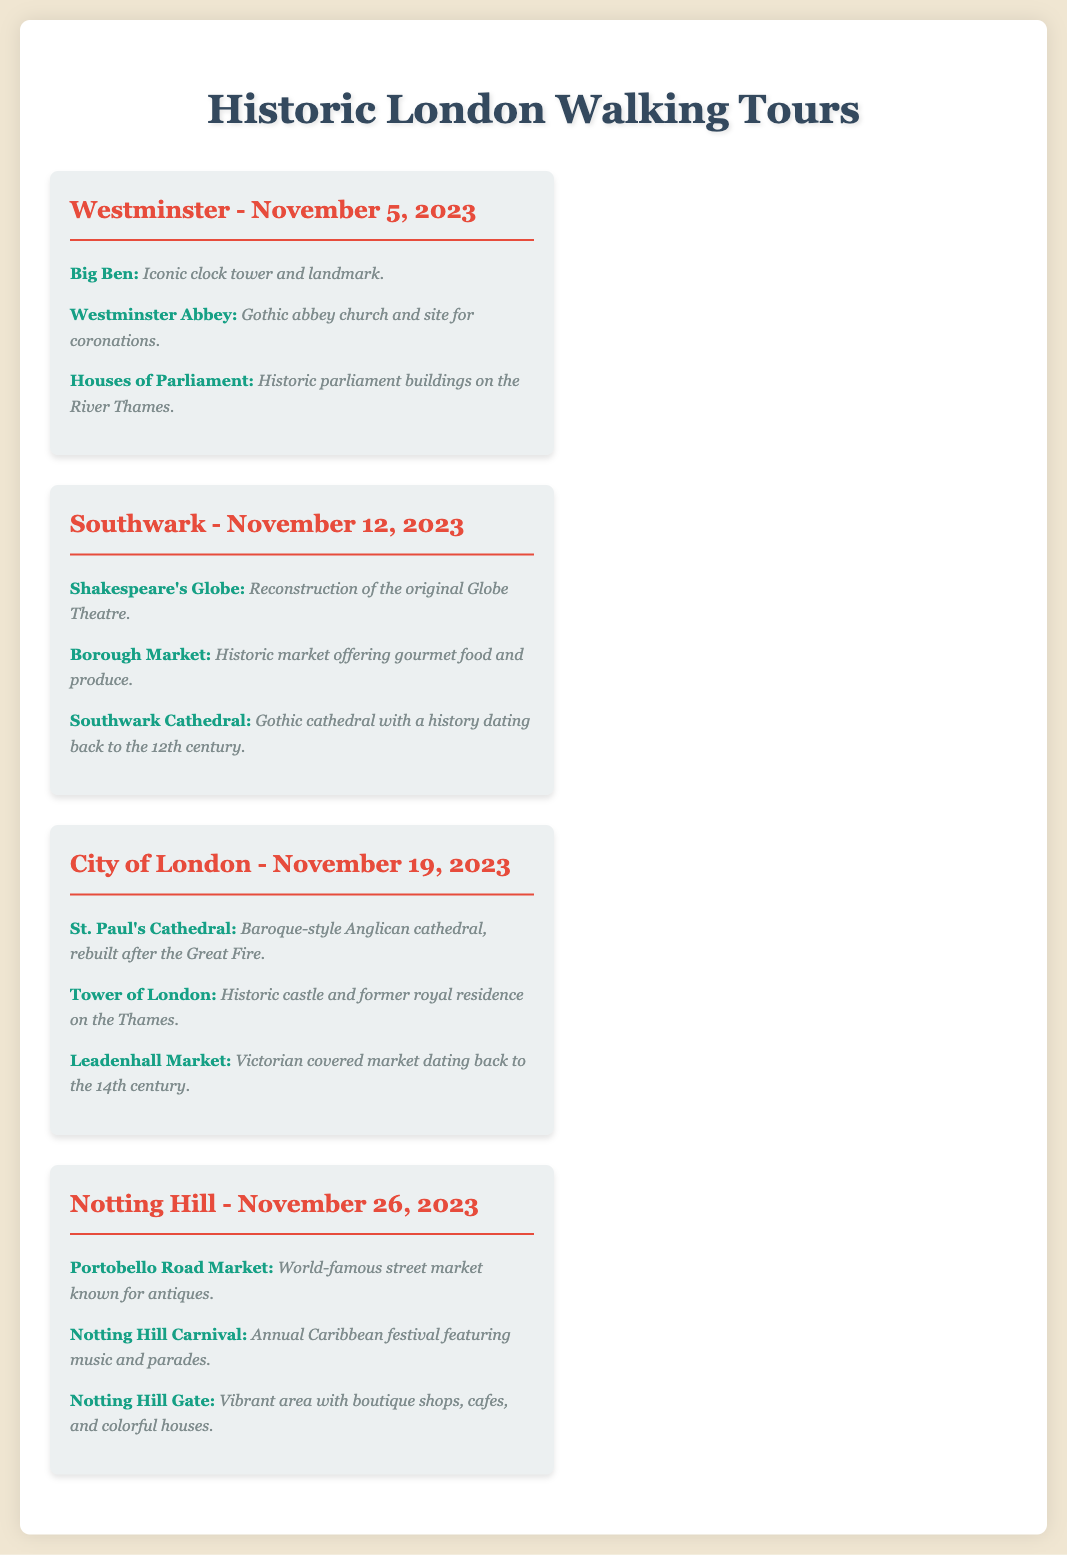What is the date of the Westminster walking tour? The Westminster walking tour is scheduled for November 5, 2023, as listed in the document.
Answer: November 5, 2023 Which landmark is an iconic clock tower? The document specifies that Big Ben is an iconic clock tower and landmark in Westminster.
Answer: Big Ben What historic site is known for its Gothic architecture? Westminster Abbey is identified in the document as a Gothic abbey church and site for coronations.
Answer: Westminster Abbey How many tours are scheduled in November 2023? The document lists four different walking tours scheduled throughout November 2023.
Answer: Four Which market is famous for gourmet food and produce? The document mentions Borough Market as the historic market offering gourmet food and produce in Southwark.
Answer: Borough Market What is a notable feature of St. Paul's Cathedral? The document states that St. Paul's Cathedral is a Baroque-style Anglican cathedral, rebuilt after the Great Fire.
Answer: Baroque-style Which neighborhood's tour features Portobello Road Market? The document indicates that the Notting Hill tour highlights the Portobello Road Market, known for antiques.
Answer: Notting Hill What is the focus of the Notting Hill Carnival? The Notting Hill Carnival is described as an annual Caribbean festival featuring music and parades in the document.
Answer: Music and parades 